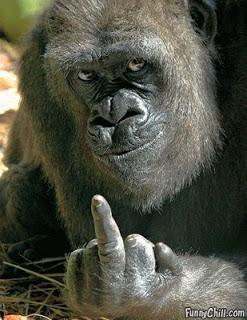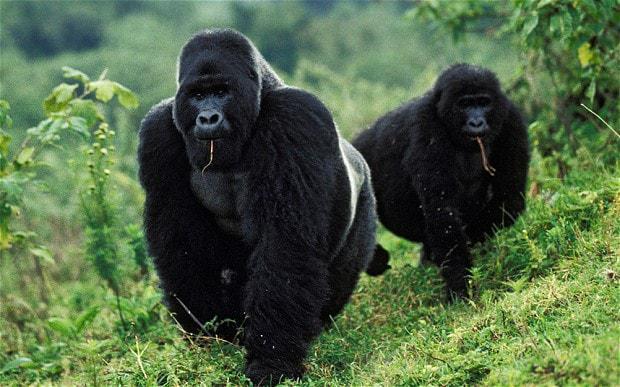The first image is the image on the left, the second image is the image on the right. Given the left and right images, does the statement "There are exactly three animals." hold true? Answer yes or no. Yes. The first image is the image on the left, the second image is the image on the right. Considering the images on both sides, is "An image shows at least one forward-facing gorilla with something stick-like in its mouth." valid? Answer yes or no. Yes. 